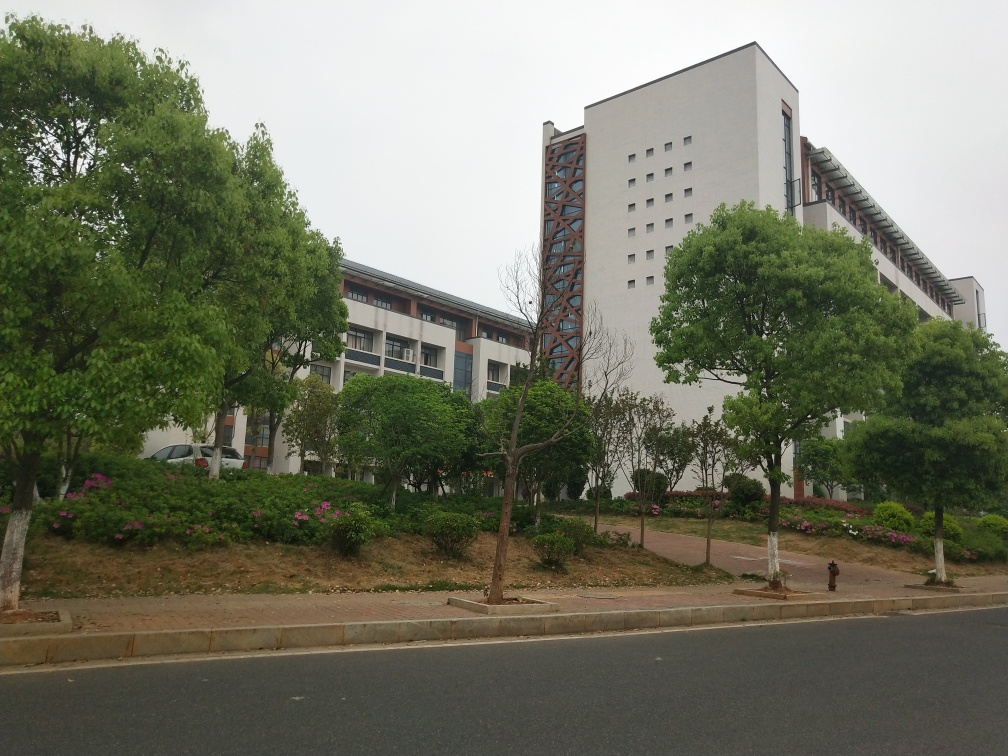Can you tell what season it might be? Judging from the image, it appears to be spring or summer based on the fullness of tree leaves and the blooming flowers. There's no sign of seasonal foliage colors or bare branches that would indicate autumn or winter. 